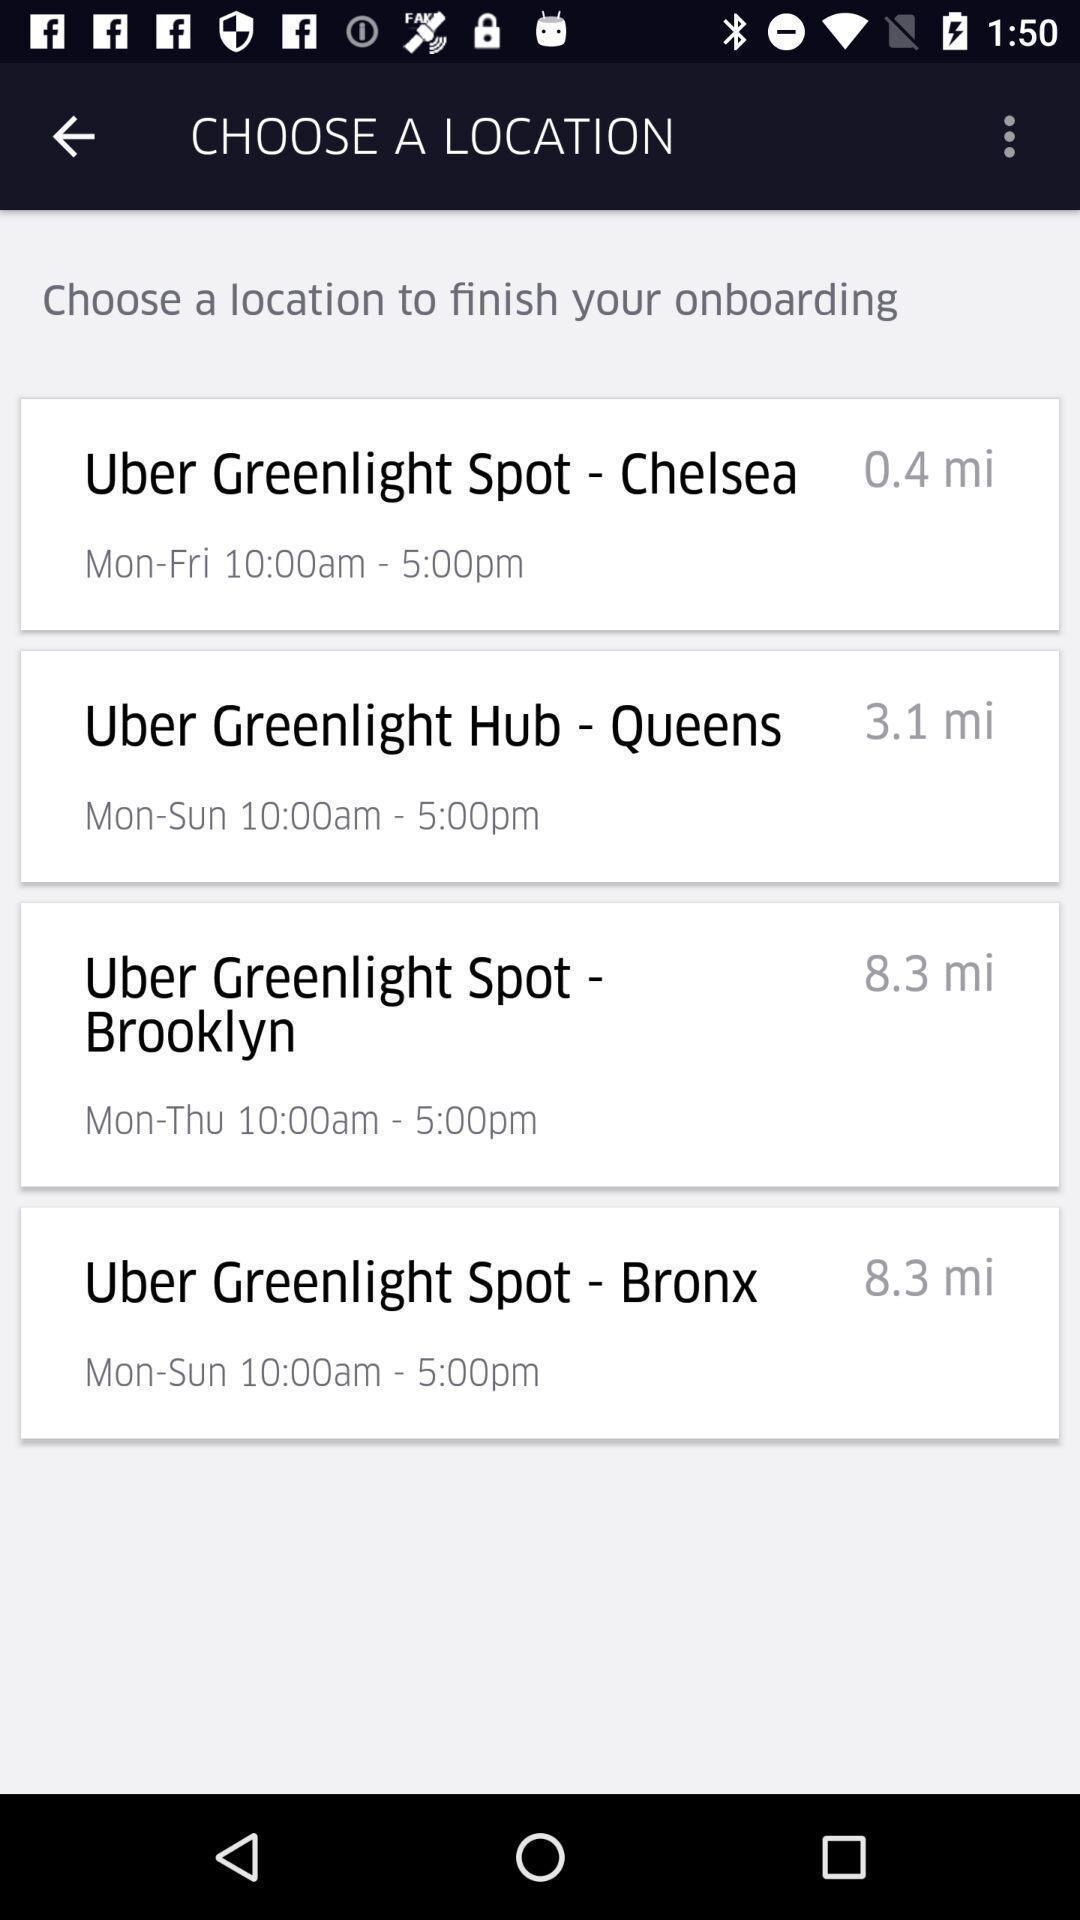Provide a detailed account of this screenshot. Screen displaying a list of multiple locations data. 